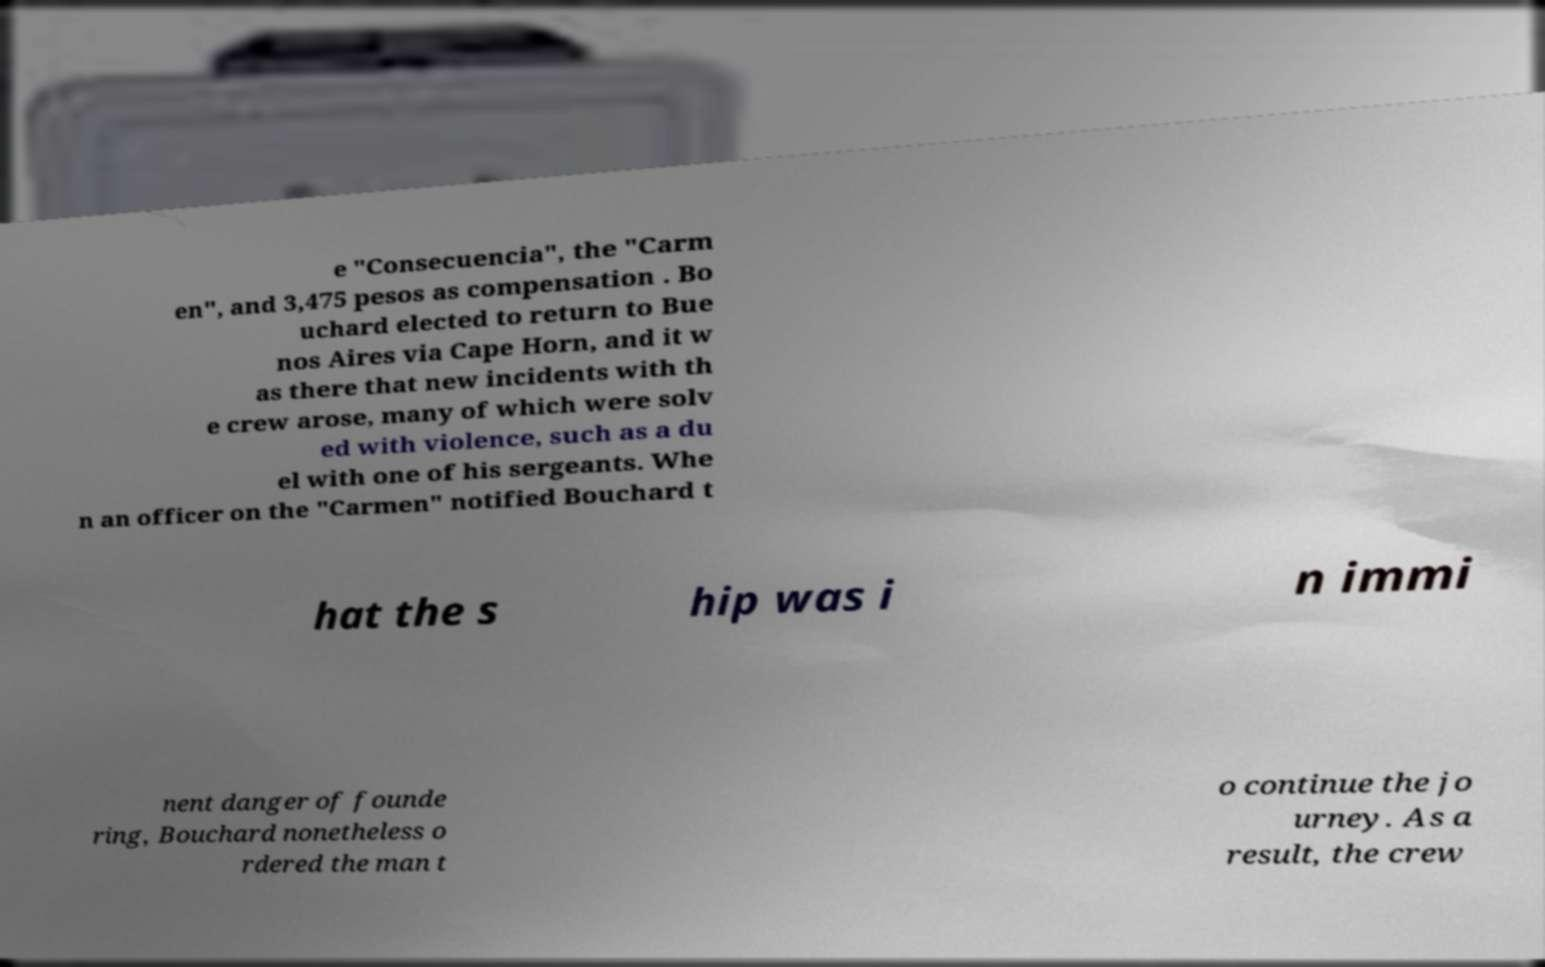Please identify and transcribe the text found in this image. e "Consecuencia", the "Carm en", and 3,475 pesos as compensation . Bo uchard elected to return to Bue nos Aires via Cape Horn, and it w as there that new incidents with th e crew arose, many of which were solv ed with violence, such as a du el with one of his sergeants. Whe n an officer on the "Carmen" notified Bouchard t hat the s hip was i n immi nent danger of founde ring, Bouchard nonetheless o rdered the man t o continue the jo urney. As a result, the crew 